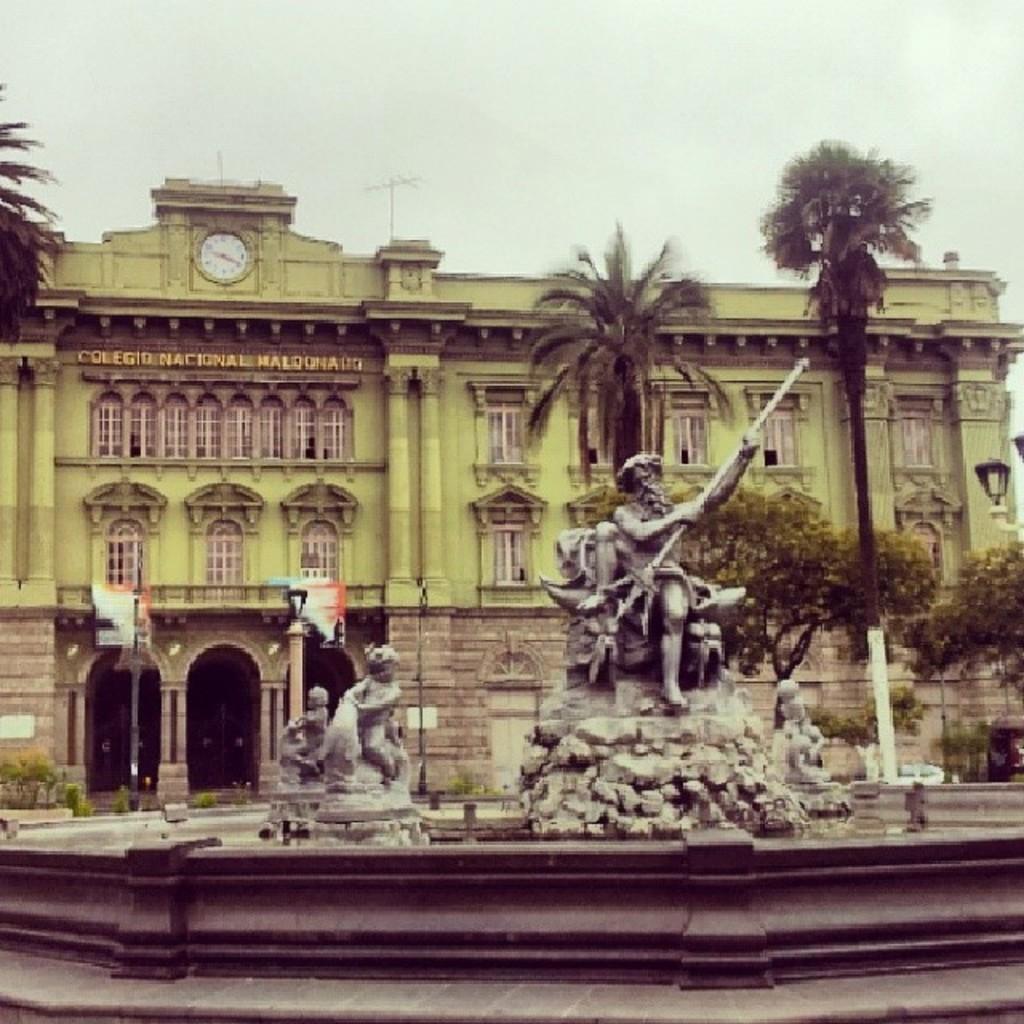In one or two sentences, can you explain what this image depicts? In this picture there are few statues and there are few trees and a building in the background. 